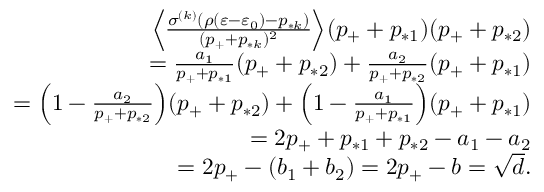Convert formula to latex. <formula><loc_0><loc_0><loc_500><loc_500>\begin{array} { r } { \left \langle \frac { \sigma ^ { ( k ) } ( \rho ( \varepsilon - \varepsilon _ { 0 } ) - p _ { * k } ) } { ( p _ { + } + p _ { * k } ) ^ { 2 } } \right \rangle ( p _ { + } + p _ { * 1 } ) ( p _ { + } + p _ { * 2 } ) } \\ { = \frac { a _ { 1 } } { p _ { + } + p _ { * 1 } } ( p _ { + } + p _ { * 2 } ) + \frac { a _ { 2 } } { p _ { + } + p _ { * 2 } } ( p _ { + } + p _ { * 1 } ) } \\ { = \left ( 1 - \frac { a _ { 2 } } { p _ { + } + p _ { * 2 } } \right ) ( p _ { + } + p _ { * 2 } ) + \left ( 1 - \frac { a _ { 1 } } { p _ { + } + p _ { * 1 } } \right ) ( p _ { + } + p _ { * 1 } ) } \\ { = 2 p _ { + } + p _ { * 1 } + p _ { * 2 } - a _ { 1 } - a _ { 2 } } \\ { = 2 p _ { + } - ( b _ { 1 } + b _ { 2 } ) = 2 p _ { + } - b = \sqrt { d } . } \end{array}</formula> 